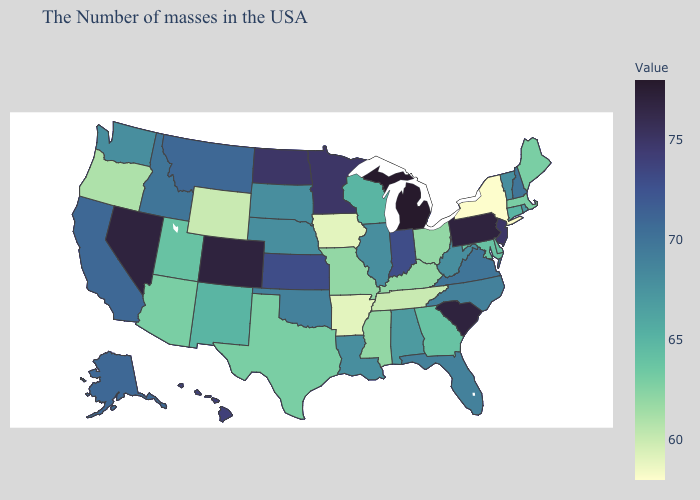Among the states that border Rhode Island , which have the highest value?
Keep it brief. Connecticut. Does Nevada have the highest value in the West?
Concise answer only. Yes. Is the legend a continuous bar?
Be succinct. Yes. Does Michigan have the highest value in the MidWest?
Answer briefly. Yes. Does Louisiana have the lowest value in the USA?
Write a very short answer. No. Does Wisconsin have the highest value in the MidWest?
Give a very brief answer. No. Is the legend a continuous bar?
Be succinct. Yes. Is the legend a continuous bar?
Short answer required. Yes. Does Connecticut have a lower value than Mississippi?
Answer briefly. No. 